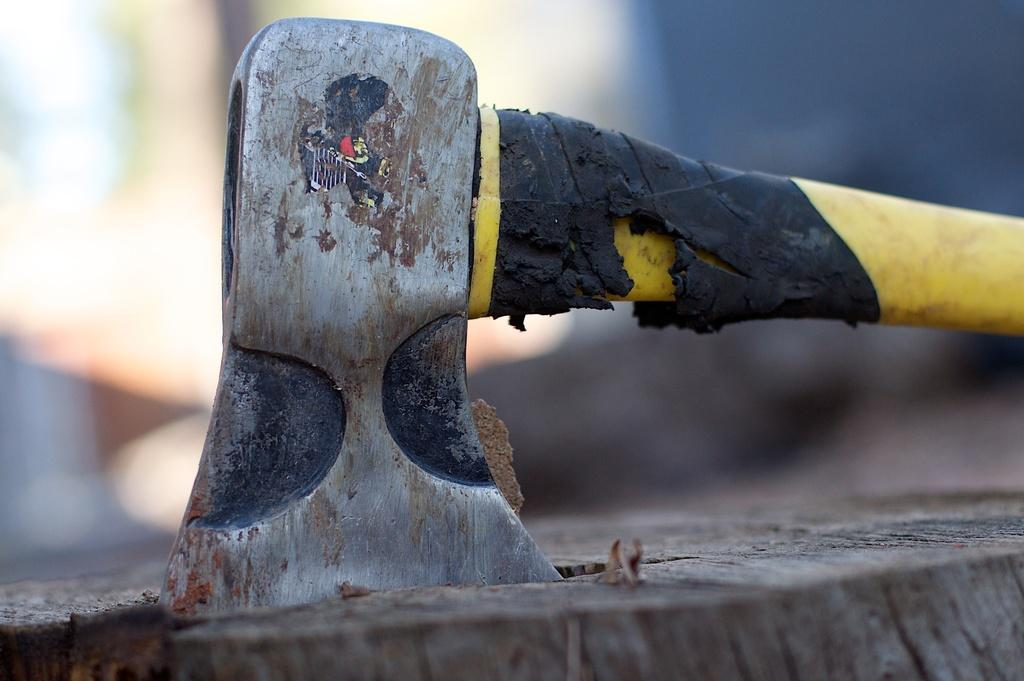What object can be seen in the image? There is an axe in the image. Where is the axe located? The axe is on a wooden surface. Can you describe the background of the image? The background of the image is blurry. How many apples are on the axe in the image? There are no apples present in the image. What type of home is visible in the background of the image? There is no home visible in the image; the background is blurry. 